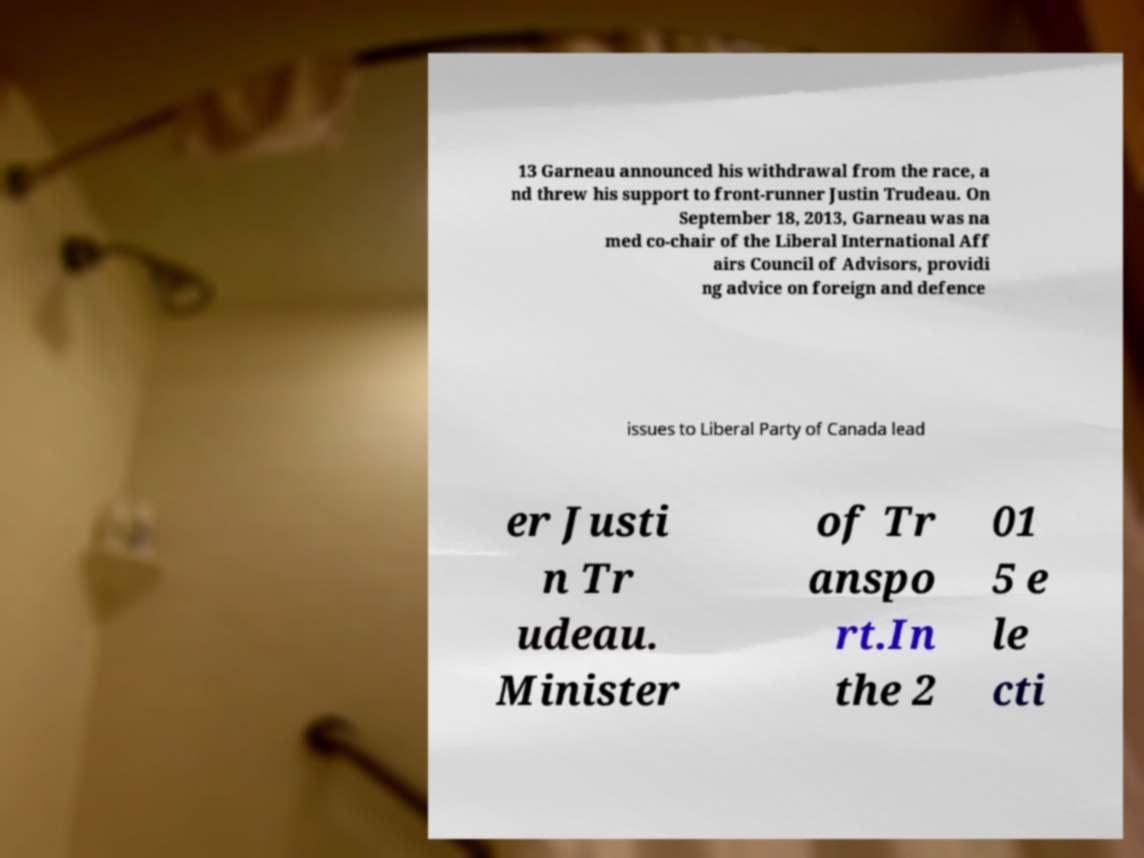Please identify and transcribe the text found in this image. 13 Garneau announced his withdrawal from the race, a nd threw his support to front-runner Justin Trudeau. On September 18, 2013, Garneau was na med co-chair of the Liberal International Aff airs Council of Advisors, providi ng advice on foreign and defence issues to Liberal Party of Canada lead er Justi n Tr udeau. Minister of Tr anspo rt.In the 2 01 5 e le cti 